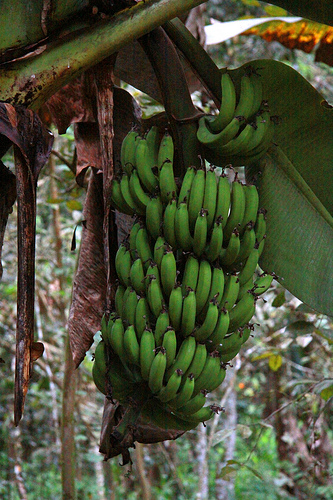Please construct a realistic scenario involving the people who might interact with these bananas. In a rural setting, a farmer wakes up early to check on the banana plantation, inspecting the bunches for their progress. The farmer, perhaps an experienced and observant individual, notes the health of the bananas and the condition of the leaves. They might trim away any overly dried leaves to ensure the plant's continued growth and health. Later in the day, the farmer's family joins in, possibly children laughing and playing nearby, adding a sense of life and vibrancy to the scene. As the day ends, the farmer prepares for the eventual harvest, knowing that soon these bananas will make their way to market, providing sustenance and income. How might an ecologist describe this image? An ecologist would likely describe this image as a thriving example of a tropical ecosystem, with the bananas representing both an important food source and part of the biodiversity of the area. They might note the interplay between the banana plant and its surrounding environment, discussing how the plant supports various forms of life, from insects to mammals. The large leaves provide shelter and moisture, creating microhabitats within the plantation. The dried leaves would be seen as part of the natural lifecycle, contributing organic matter back into the soil and supporting a range of decomposers in the ecosystem. 